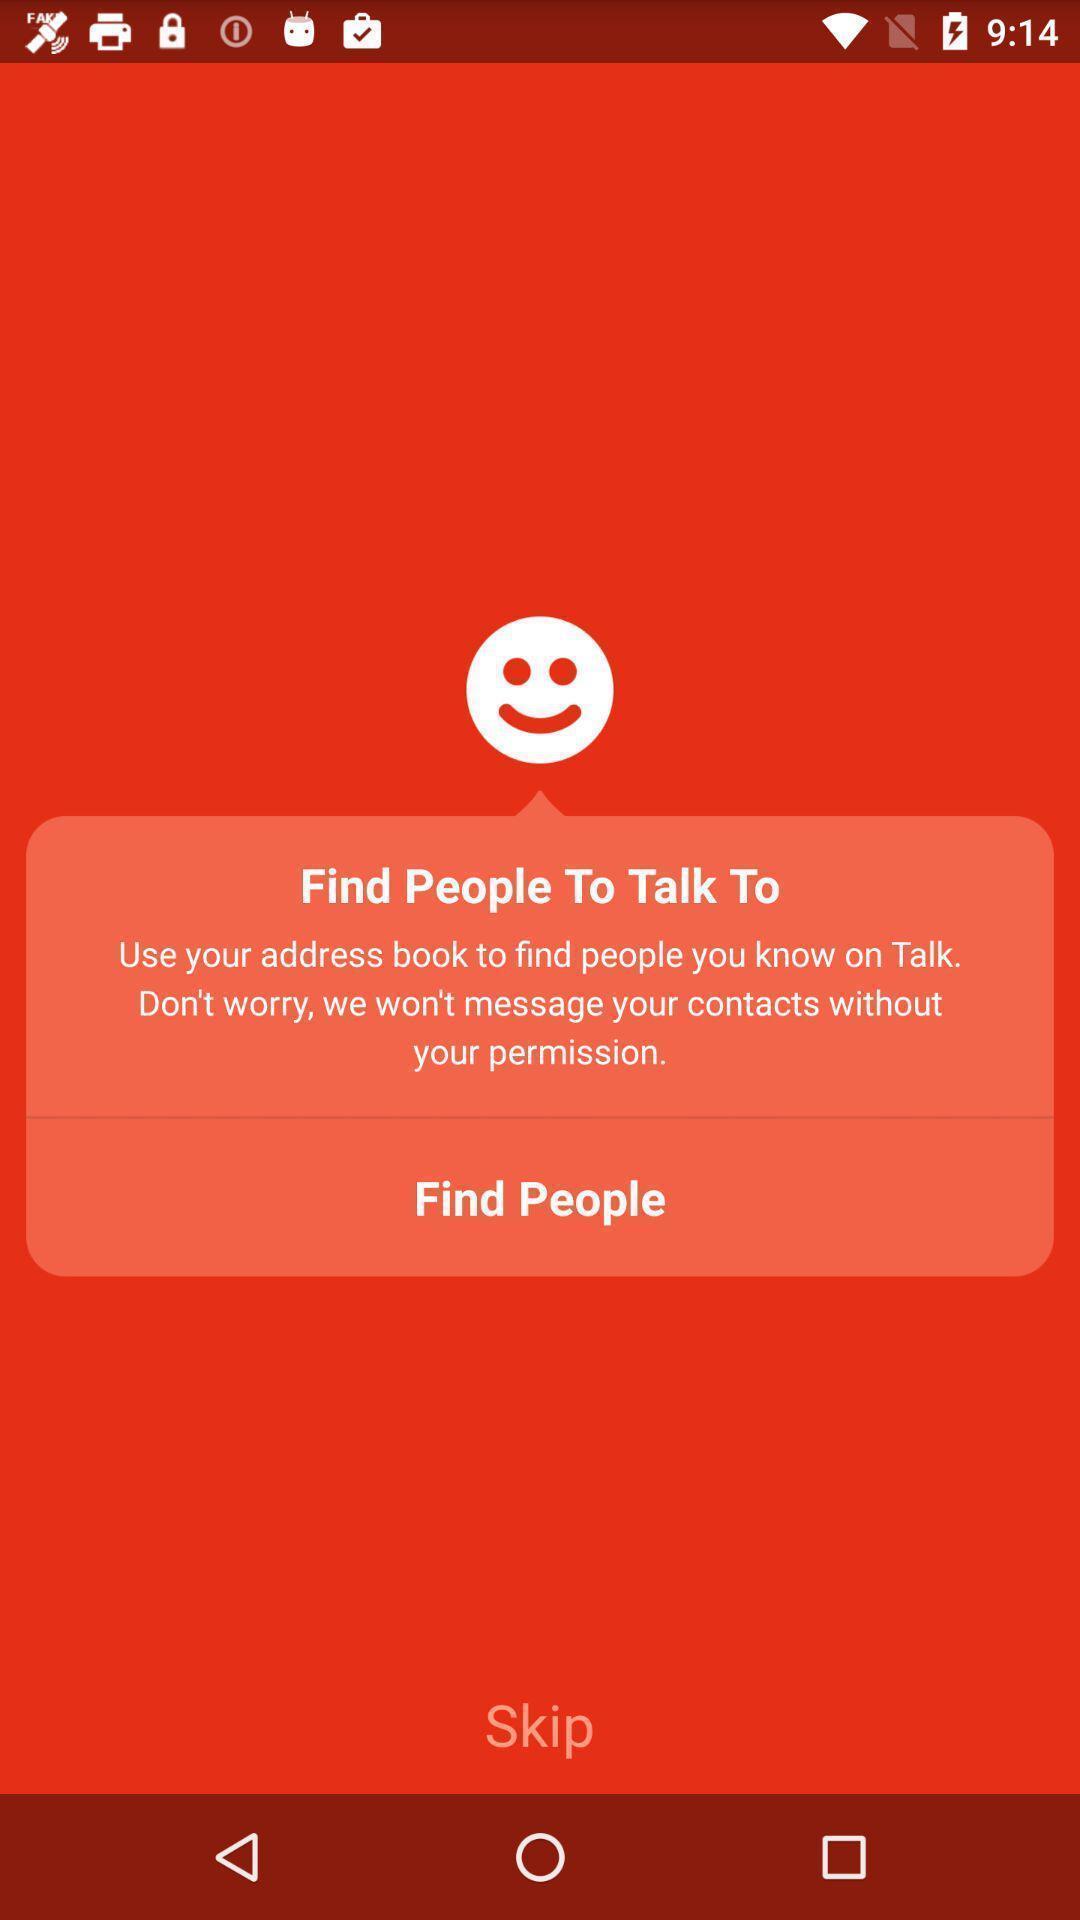Provide a textual representation of this image. Welcome page. 